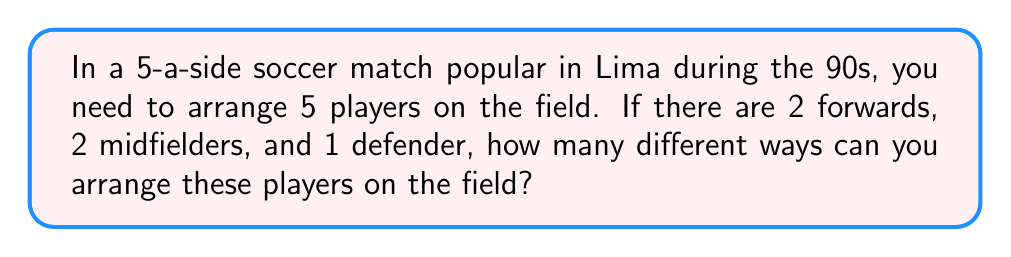Can you answer this question? Let's approach this step-by-step:

1) First, we need to understand that this is a permutation problem. We are arranging 5 distinct positions on the field.

2) However, we have some identical elements: 2 forwards and 2 midfielders. This means we need to use the permutation formula for repeated elements.

3) The formula for permutations with repeated elements is:

   $$\frac{n!}{n_1!n_2!...n_k!}$$

   Where $n$ is the total number of elements, and $n_1, n_2, ..., n_k$ are the numbers of each type of repeated element.

4) In our case:
   - $n = 5$ (total players)
   - $n_1 = 2$ (forwards)
   - $n_2 = 2$ (midfielders)
   - $n_3 = 1$ (defender)

5) Plugging these into our formula:

   $$\frac{5!}{2!2!1!}$$

6) Let's calculate this:
   
   $$\frac{5 * 4 * 3 * 2 * 1}{(2 * 1)(2 * 1)(1)} = \frac{120}{4} = 30$$

Therefore, there are 30 different ways to arrange the players on the field.
Answer: 30 